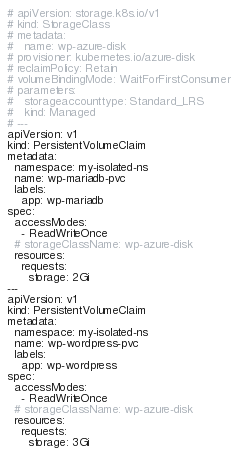<code> <loc_0><loc_0><loc_500><loc_500><_YAML_># apiVersion: storage.k8s.io/v1
# kind: StorageClass
# metadata:
#   name: wp-azure-disk
# provisioner: kubernetes.io/azure-disk
# reclaimPolicy: Retain
# volumeBindingMode: WaitForFirstConsumer
# parameters:
#   storageaccounttype: Standard_LRS
#   kind: Managed
# ---
apiVersion: v1
kind: PersistentVolumeClaim
metadata:
  namespace: my-isolated-ns
  name: wp-mariadb-pvc
  labels:
    app: wp-mariadb
spec:
  accessModes:
    - ReadWriteOnce
  # storageClassName: wp-azure-disk
  resources:
    requests:
      storage: 2Gi
---
apiVersion: v1
kind: PersistentVolumeClaim
metadata:
  namespace: my-isolated-ns
  name: wp-wordpress-pvc
  labels:
    app: wp-wordpress
spec:
  accessModes:
    - ReadWriteOnce
  # storageClassName: wp-azure-disk
  resources:
    requests:
      storage: 3Gi
</code> 